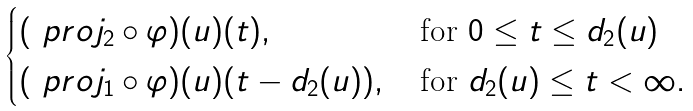Convert formula to latex. <formula><loc_0><loc_0><loc_500><loc_500>\begin{cases} ( \ p r o j _ { 2 } \circ \varphi ) ( u ) ( t ) , \, & \text {for $0\leq t\leq d_{2}(u)$} \\ ( \ p r o j _ { 1 } \circ \varphi ) ( u ) ( t - d _ { 2 } ( u ) ) , \, & \text {for $d_{2}(u)\leq t<\infty$} . \end{cases}</formula> 